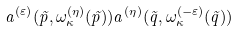Convert formula to latex. <formula><loc_0><loc_0><loc_500><loc_500>a ^ { ( \varepsilon ) } ( \vec { p } , \omega ^ { ( \eta ) } _ { \kappa } ( \vec { p } ) ) a ^ { ( \eta ) } ( \vec { q } , \omega ^ { ( - \varepsilon ) } _ { \kappa } ( \vec { q } ) )</formula> 